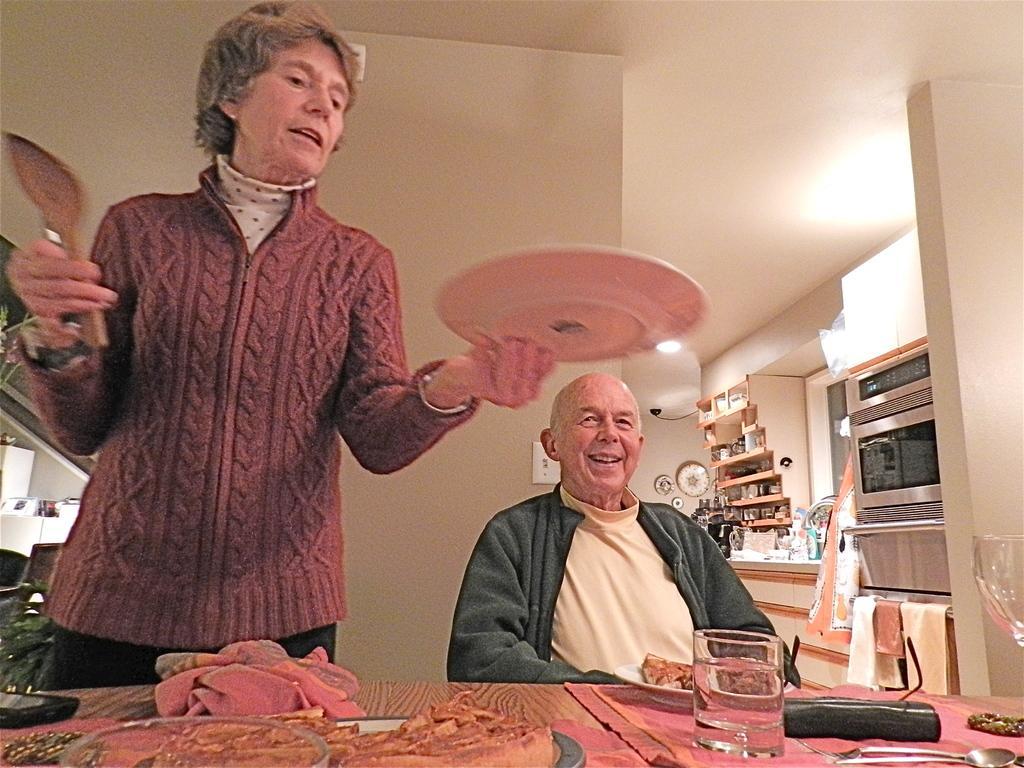Please provide a concise description of this image. In this image I can see two persons where one is standing and one is sitting. I can also see one of them is holding a spoon and a plate. In the front of them I can see a table and on it I can see two glasses, few clothes, few plates and food. I can also see a spoon on the bottom right side of the image. In the background I can see a microwave, few clothes and number of things on the shelves. On the bottom left side I can see a plant and I can also see few lights in the background. 